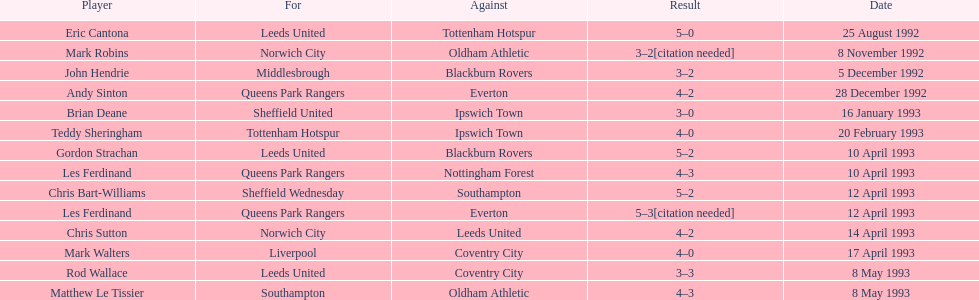On what team can john hendrie be found playing? Middlesbrough. 